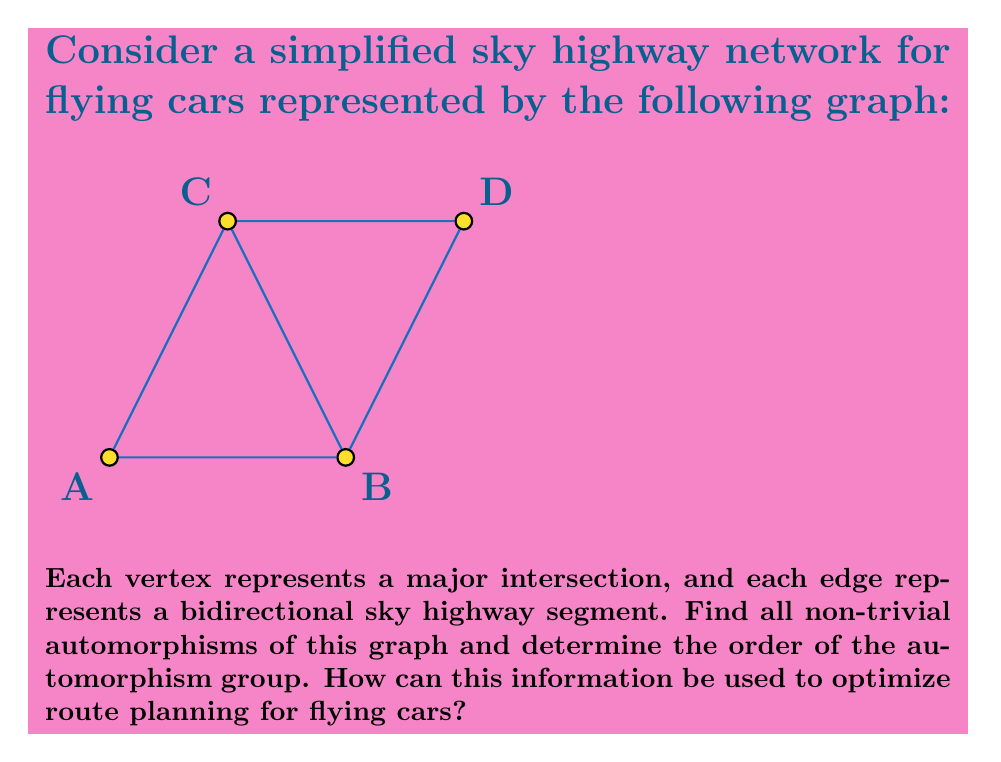Could you help me with this problem? To solve this problem, we'll follow these steps:

1) First, let's identify the automorphisms of the graph:
   - The graph has a symmetry across the diagonal from A to D.
   - This symmetry corresponds to swapping B and C while keeping A and D fixed.

2) The automorphisms of this graph are:
   - The identity automorphism (leaving all vertices in place)
   - The automorphism that swaps B and C

3) To determine the order of the automorphism group:
   - We have identified 2 automorphisms
   - The order of the automorphism group is therefore 2

4) This group is isomorphic to $\mathbb{Z}_2$, the cyclic group of order 2.

5) How this information can be used to optimize route planning:
   - The automorphism tells us that routes involving B and C are interchangeable.
   - For example, the paths A-B-D and A-C-D are equivalent in terms of network structure.
   - This means that when planning routes, we only need to calculate one of these options, reducing computational complexity.
   - In a larger network, identifying such symmetries could significantly reduce the number of route calculations needed.
   - It also implies that traffic load could be balanced between B and C, as they play structurally equivalent roles in the network.

The order of the automorphism group (2) indicates that there are two structurally distinct configurations of the network. This information can be used to create two master plans for traffic flow, which can be alternated based on real-time conditions to optimize traffic distribution.
Answer: Automorphism group: $\{\text{id}, (B\;C)\}$; Order: 2; Isomorphic to $\mathbb{Z}_2$. Optimizes route planning by identifying equivalent paths and reducing computation. 